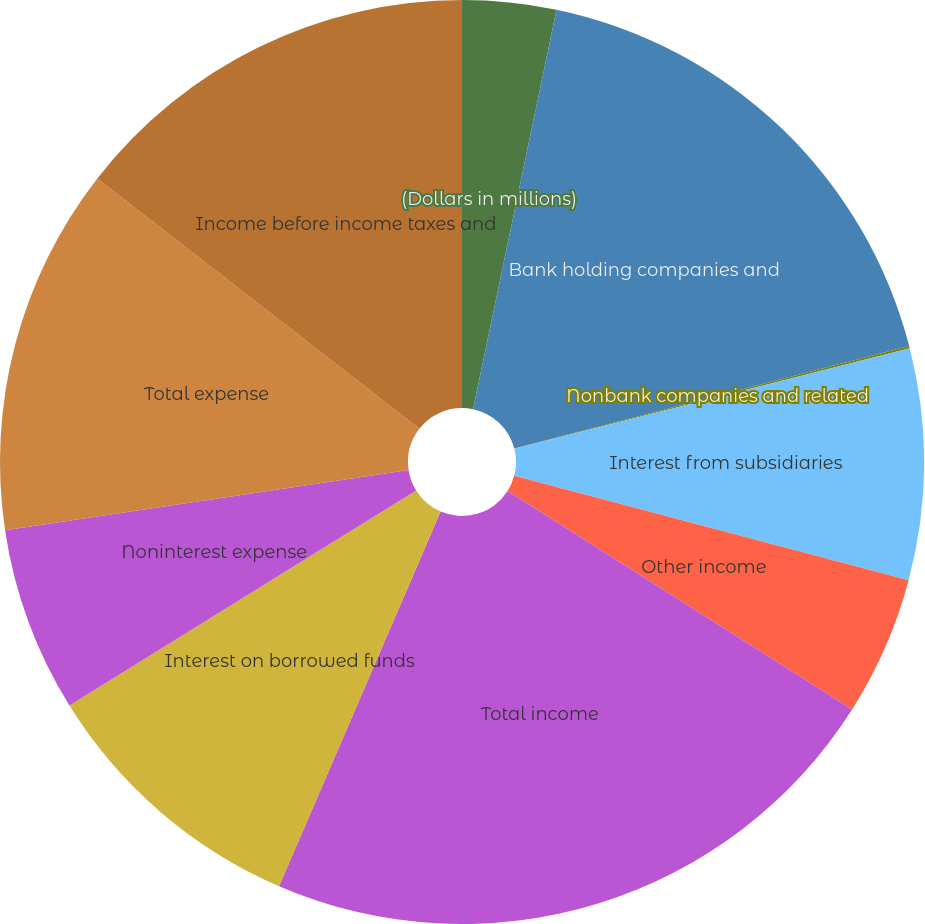<chart> <loc_0><loc_0><loc_500><loc_500><pie_chart><fcel>(Dollars in millions)<fcel>Bank holding companies and<fcel>Nonbank companies and related<fcel>Interest from subsidiaries<fcel>Other income<fcel>Total income<fcel>Interest on borrowed funds<fcel>Noninterest expense<fcel>Total expense<fcel>Income before income taxes and<nl><fcel>3.28%<fcel>17.68%<fcel>0.08%<fcel>8.08%<fcel>4.88%<fcel>22.48%<fcel>9.68%<fcel>6.48%<fcel>12.88%<fcel>14.48%<nl></chart> 